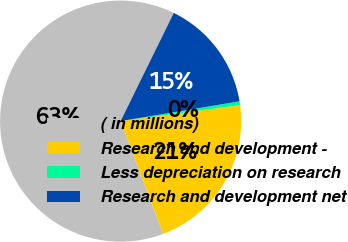<chart> <loc_0><loc_0><loc_500><loc_500><pie_chart><fcel>( in millions)<fcel>Research and development -<fcel>Less depreciation on research<fcel>Research and development net<nl><fcel>63.02%<fcel>21.37%<fcel>0.5%<fcel>15.11%<nl></chart> 